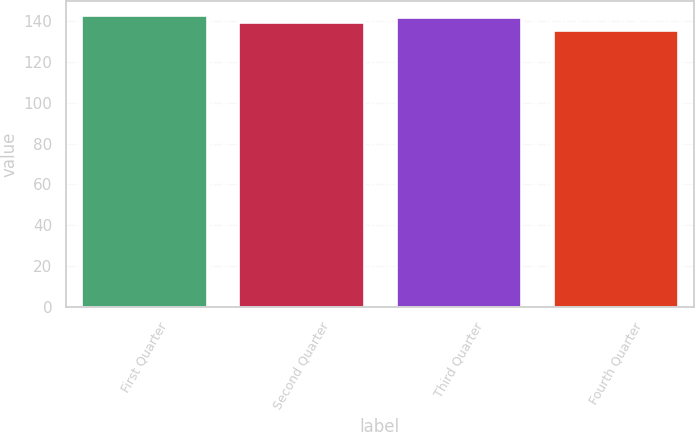Convert chart to OTSL. <chart><loc_0><loc_0><loc_500><loc_500><bar_chart><fcel>First Quarter<fcel>Second Quarter<fcel>Third Quarter<fcel>Fourth Quarter<nl><fcel>142.75<fcel>139.56<fcel>141.77<fcel>135.4<nl></chart> 